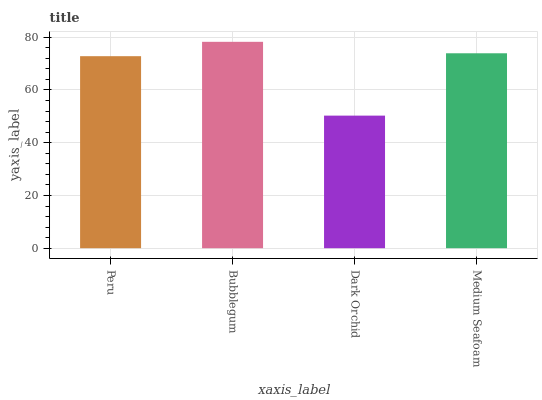Is Dark Orchid the minimum?
Answer yes or no. Yes. Is Bubblegum the maximum?
Answer yes or no. Yes. Is Bubblegum the minimum?
Answer yes or no. No. Is Dark Orchid the maximum?
Answer yes or no. No. Is Bubblegum greater than Dark Orchid?
Answer yes or no. Yes. Is Dark Orchid less than Bubblegum?
Answer yes or no. Yes. Is Dark Orchid greater than Bubblegum?
Answer yes or no. No. Is Bubblegum less than Dark Orchid?
Answer yes or no. No. Is Medium Seafoam the high median?
Answer yes or no. Yes. Is Peru the low median?
Answer yes or no. Yes. Is Peru the high median?
Answer yes or no. No. Is Dark Orchid the low median?
Answer yes or no. No. 